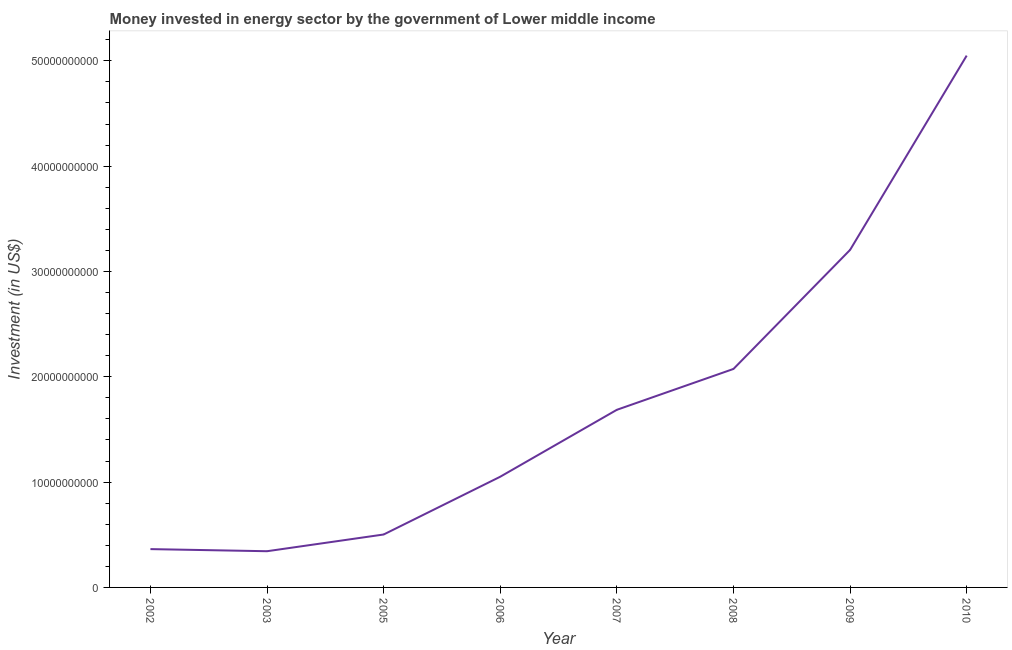What is the investment in energy in 2005?
Your answer should be compact. 5.03e+09. Across all years, what is the maximum investment in energy?
Offer a terse response. 5.05e+1. Across all years, what is the minimum investment in energy?
Give a very brief answer. 3.44e+09. In which year was the investment in energy minimum?
Your answer should be compact. 2003. What is the sum of the investment in energy?
Your response must be concise. 1.43e+11. What is the difference between the investment in energy in 2003 and 2008?
Provide a short and direct response. -1.73e+1. What is the average investment in energy per year?
Your answer should be very brief. 1.78e+1. What is the median investment in energy?
Keep it short and to the point. 1.37e+1. In how many years, is the investment in energy greater than 28000000000 US$?
Provide a short and direct response. 2. What is the ratio of the investment in energy in 2002 to that in 2005?
Offer a terse response. 0.72. What is the difference between the highest and the second highest investment in energy?
Make the answer very short. 1.84e+1. Is the sum of the investment in energy in 2009 and 2010 greater than the maximum investment in energy across all years?
Make the answer very short. Yes. What is the difference between the highest and the lowest investment in energy?
Make the answer very short. 4.71e+1. In how many years, is the investment in energy greater than the average investment in energy taken over all years?
Your answer should be compact. 3. Does the investment in energy monotonically increase over the years?
Give a very brief answer. No. How many lines are there?
Give a very brief answer. 1. Are the values on the major ticks of Y-axis written in scientific E-notation?
Your response must be concise. No. Does the graph contain grids?
Your answer should be compact. No. What is the title of the graph?
Provide a succinct answer. Money invested in energy sector by the government of Lower middle income. What is the label or title of the Y-axis?
Offer a very short reply. Investment (in US$). What is the Investment (in US$) of 2002?
Your answer should be very brief. 3.64e+09. What is the Investment (in US$) of 2003?
Offer a very short reply. 3.44e+09. What is the Investment (in US$) in 2005?
Offer a terse response. 5.03e+09. What is the Investment (in US$) of 2006?
Provide a short and direct response. 1.05e+1. What is the Investment (in US$) of 2007?
Give a very brief answer. 1.69e+1. What is the Investment (in US$) of 2008?
Your answer should be very brief. 2.07e+1. What is the Investment (in US$) in 2009?
Provide a short and direct response. 3.20e+1. What is the Investment (in US$) in 2010?
Keep it short and to the point. 5.05e+1. What is the difference between the Investment (in US$) in 2002 and 2003?
Give a very brief answer. 2.00e+08. What is the difference between the Investment (in US$) in 2002 and 2005?
Keep it short and to the point. -1.39e+09. What is the difference between the Investment (in US$) in 2002 and 2006?
Provide a succinct answer. -6.87e+09. What is the difference between the Investment (in US$) in 2002 and 2007?
Offer a terse response. -1.32e+1. What is the difference between the Investment (in US$) in 2002 and 2008?
Offer a terse response. -1.71e+1. What is the difference between the Investment (in US$) in 2002 and 2009?
Your response must be concise. -2.84e+1. What is the difference between the Investment (in US$) in 2002 and 2010?
Offer a very short reply. -4.69e+1. What is the difference between the Investment (in US$) in 2003 and 2005?
Keep it short and to the point. -1.59e+09. What is the difference between the Investment (in US$) in 2003 and 2006?
Provide a short and direct response. -7.07e+09. What is the difference between the Investment (in US$) in 2003 and 2007?
Offer a terse response. -1.34e+1. What is the difference between the Investment (in US$) in 2003 and 2008?
Keep it short and to the point. -1.73e+1. What is the difference between the Investment (in US$) in 2003 and 2009?
Make the answer very short. -2.86e+1. What is the difference between the Investment (in US$) in 2003 and 2010?
Give a very brief answer. -4.71e+1. What is the difference between the Investment (in US$) in 2005 and 2006?
Offer a very short reply. -5.49e+09. What is the difference between the Investment (in US$) in 2005 and 2007?
Your answer should be very brief. -1.18e+1. What is the difference between the Investment (in US$) in 2005 and 2008?
Make the answer very short. -1.57e+1. What is the difference between the Investment (in US$) in 2005 and 2009?
Ensure brevity in your answer.  -2.70e+1. What is the difference between the Investment (in US$) in 2005 and 2010?
Make the answer very short. -4.55e+1. What is the difference between the Investment (in US$) in 2006 and 2007?
Offer a terse response. -6.35e+09. What is the difference between the Investment (in US$) in 2006 and 2008?
Offer a terse response. -1.02e+1. What is the difference between the Investment (in US$) in 2006 and 2009?
Keep it short and to the point. -2.15e+1. What is the difference between the Investment (in US$) in 2006 and 2010?
Your answer should be compact. -4.00e+1. What is the difference between the Investment (in US$) in 2007 and 2008?
Your response must be concise. -3.88e+09. What is the difference between the Investment (in US$) in 2007 and 2009?
Ensure brevity in your answer.  -1.52e+1. What is the difference between the Investment (in US$) in 2007 and 2010?
Keep it short and to the point. -3.36e+1. What is the difference between the Investment (in US$) in 2008 and 2009?
Ensure brevity in your answer.  -1.13e+1. What is the difference between the Investment (in US$) in 2008 and 2010?
Offer a terse response. -2.98e+1. What is the difference between the Investment (in US$) in 2009 and 2010?
Provide a short and direct response. -1.84e+1. What is the ratio of the Investment (in US$) in 2002 to that in 2003?
Offer a very short reply. 1.06. What is the ratio of the Investment (in US$) in 2002 to that in 2005?
Ensure brevity in your answer.  0.72. What is the ratio of the Investment (in US$) in 2002 to that in 2006?
Make the answer very short. 0.35. What is the ratio of the Investment (in US$) in 2002 to that in 2007?
Ensure brevity in your answer.  0.22. What is the ratio of the Investment (in US$) in 2002 to that in 2008?
Provide a short and direct response. 0.17. What is the ratio of the Investment (in US$) in 2002 to that in 2009?
Offer a very short reply. 0.11. What is the ratio of the Investment (in US$) in 2002 to that in 2010?
Your answer should be compact. 0.07. What is the ratio of the Investment (in US$) in 2003 to that in 2005?
Keep it short and to the point. 0.68. What is the ratio of the Investment (in US$) in 2003 to that in 2006?
Offer a very short reply. 0.33. What is the ratio of the Investment (in US$) in 2003 to that in 2007?
Provide a short and direct response. 0.2. What is the ratio of the Investment (in US$) in 2003 to that in 2008?
Your answer should be very brief. 0.17. What is the ratio of the Investment (in US$) in 2003 to that in 2009?
Keep it short and to the point. 0.11. What is the ratio of the Investment (in US$) in 2003 to that in 2010?
Provide a succinct answer. 0.07. What is the ratio of the Investment (in US$) in 2005 to that in 2006?
Give a very brief answer. 0.48. What is the ratio of the Investment (in US$) in 2005 to that in 2007?
Provide a succinct answer. 0.3. What is the ratio of the Investment (in US$) in 2005 to that in 2008?
Offer a very short reply. 0.24. What is the ratio of the Investment (in US$) in 2005 to that in 2009?
Ensure brevity in your answer.  0.16. What is the ratio of the Investment (in US$) in 2006 to that in 2007?
Provide a succinct answer. 0.62. What is the ratio of the Investment (in US$) in 2006 to that in 2008?
Your answer should be compact. 0.51. What is the ratio of the Investment (in US$) in 2006 to that in 2009?
Your response must be concise. 0.33. What is the ratio of the Investment (in US$) in 2006 to that in 2010?
Your response must be concise. 0.21. What is the ratio of the Investment (in US$) in 2007 to that in 2008?
Give a very brief answer. 0.81. What is the ratio of the Investment (in US$) in 2007 to that in 2009?
Your response must be concise. 0.53. What is the ratio of the Investment (in US$) in 2007 to that in 2010?
Your response must be concise. 0.33. What is the ratio of the Investment (in US$) in 2008 to that in 2009?
Your answer should be very brief. 0.65. What is the ratio of the Investment (in US$) in 2008 to that in 2010?
Keep it short and to the point. 0.41. What is the ratio of the Investment (in US$) in 2009 to that in 2010?
Provide a succinct answer. 0.64. 